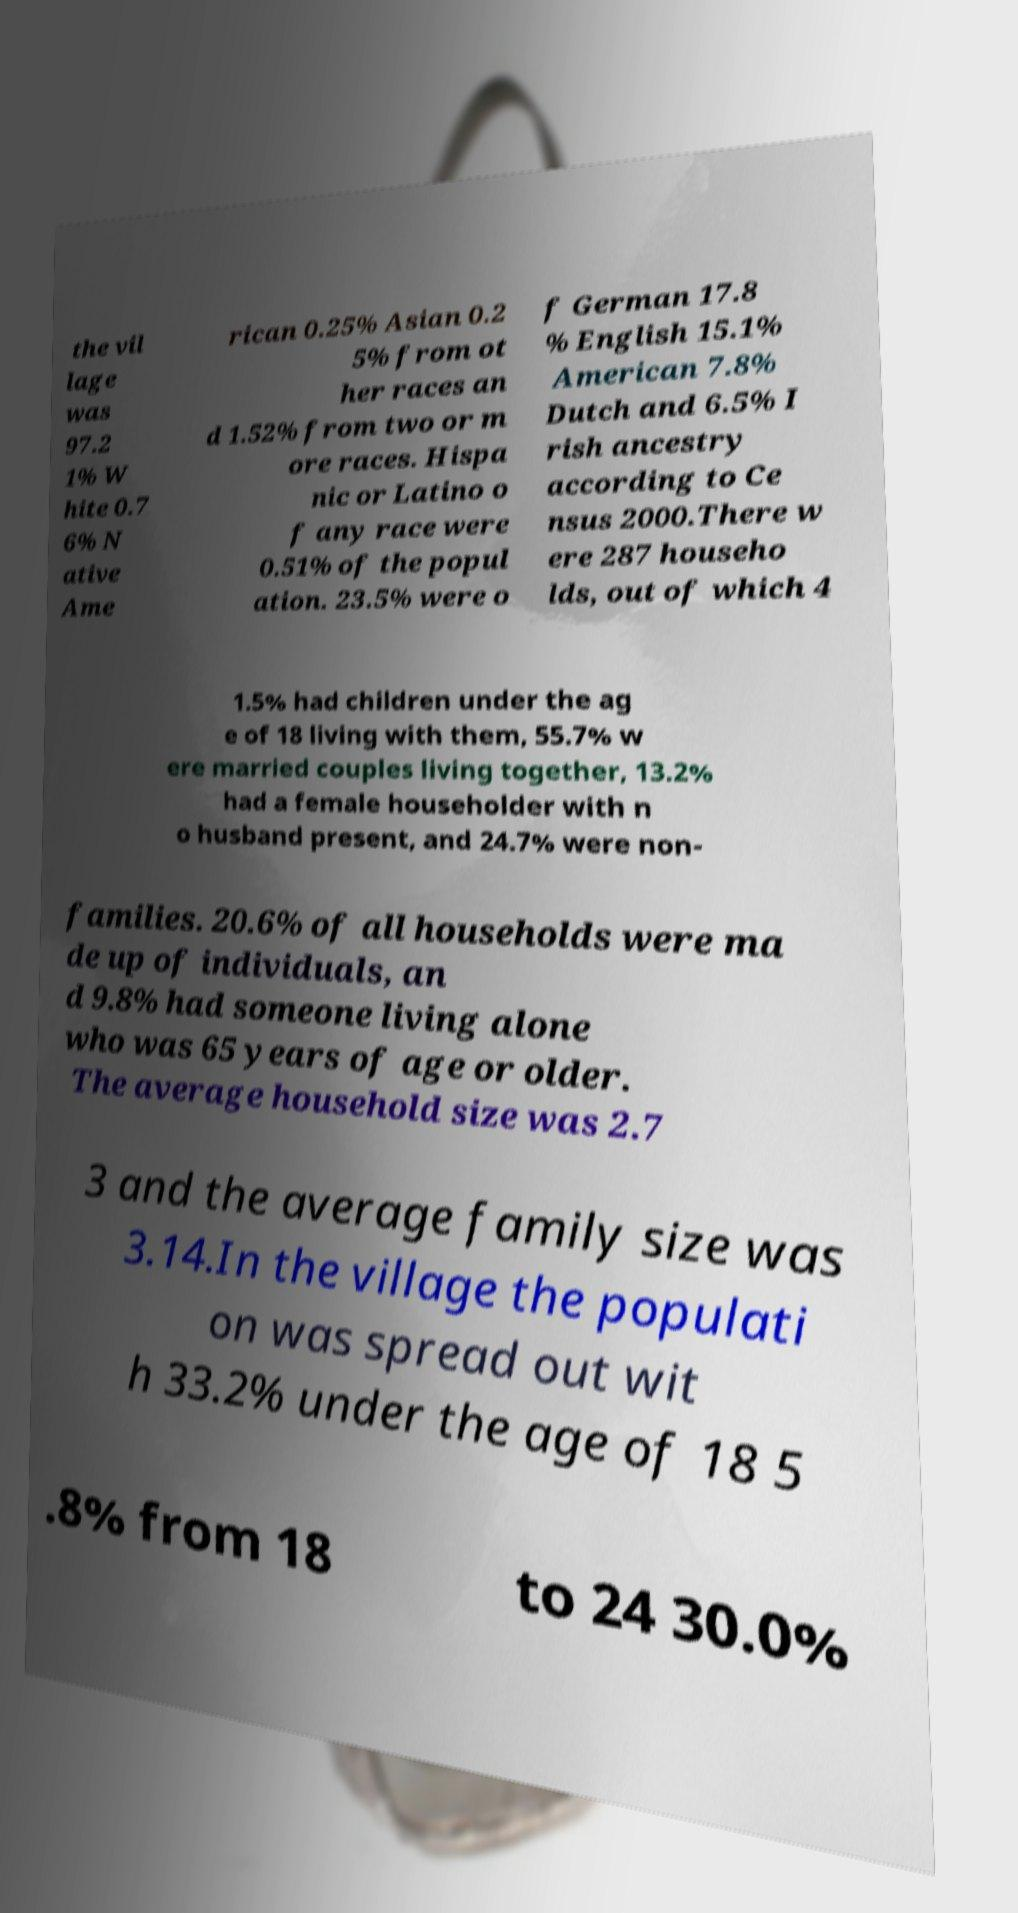Can you accurately transcribe the text from the provided image for me? the vil lage was 97.2 1% W hite 0.7 6% N ative Ame rican 0.25% Asian 0.2 5% from ot her races an d 1.52% from two or m ore races. Hispa nic or Latino o f any race were 0.51% of the popul ation. 23.5% were o f German 17.8 % English 15.1% American 7.8% Dutch and 6.5% I rish ancestry according to Ce nsus 2000.There w ere 287 househo lds, out of which 4 1.5% had children under the ag e of 18 living with them, 55.7% w ere married couples living together, 13.2% had a female householder with n o husband present, and 24.7% were non- families. 20.6% of all households were ma de up of individuals, an d 9.8% had someone living alone who was 65 years of age or older. The average household size was 2.7 3 and the average family size was 3.14.In the village the populati on was spread out wit h 33.2% under the age of 18 5 .8% from 18 to 24 30.0% 